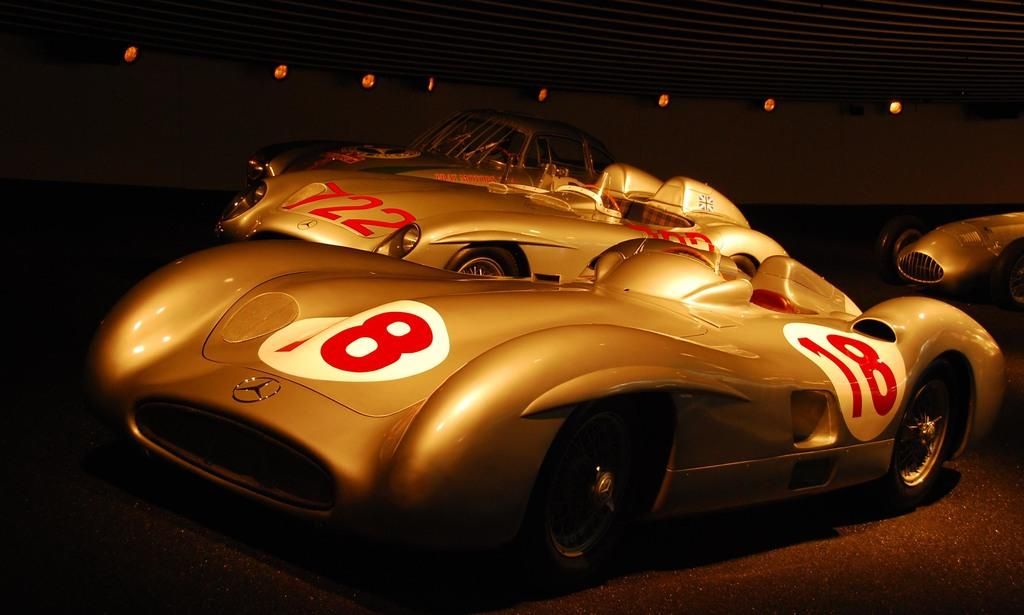What can be seen on the road in the image? There are cars on the road in the image. What is visible in the background of the image? There is a wall in the background of the image. What can be seen illuminating the scene in the image? There are lights visible in the image. What type of locket is hanging from the rearview mirror of one of the cars in the image? There is no locket visible in the image, as it focuses on the cars on the road and the wall in the background. 